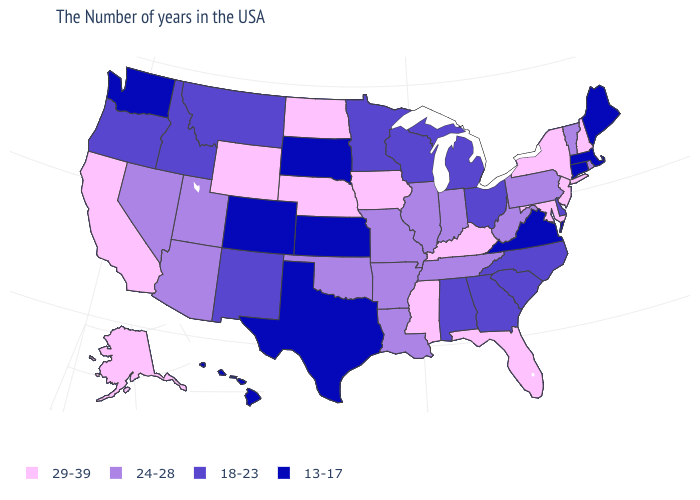How many symbols are there in the legend?
Short answer required. 4. Among the states that border New York , which have the lowest value?
Short answer required. Massachusetts, Connecticut. What is the lowest value in states that border Arizona?
Answer briefly. 13-17. What is the value of North Carolina?
Concise answer only. 18-23. What is the value of Illinois?
Write a very short answer. 24-28. Does Maine have the highest value in the USA?
Quick response, please. No. Among the states that border Ohio , which have the highest value?
Answer briefly. Kentucky. What is the value of Pennsylvania?
Keep it brief. 24-28. Among the states that border Missouri , which have the lowest value?
Be succinct. Kansas. Is the legend a continuous bar?
Short answer required. No. What is the value of Tennessee?
Short answer required. 24-28. Which states hav the highest value in the West?
Quick response, please. Wyoming, California, Alaska. What is the highest value in the USA?
Be succinct. 29-39. Name the states that have a value in the range 29-39?
Answer briefly. New Hampshire, New York, New Jersey, Maryland, Florida, Kentucky, Mississippi, Iowa, Nebraska, North Dakota, Wyoming, California, Alaska. Which states have the highest value in the USA?
Answer briefly. New Hampshire, New York, New Jersey, Maryland, Florida, Kentucky, Mississippi, Iowa, Nebraska, North Dakota, Wyoming, California, Alaska. 